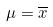<formula> <loc_0><loc_0><loc_500><loc_500>\mu = \overline { x }</formula> 